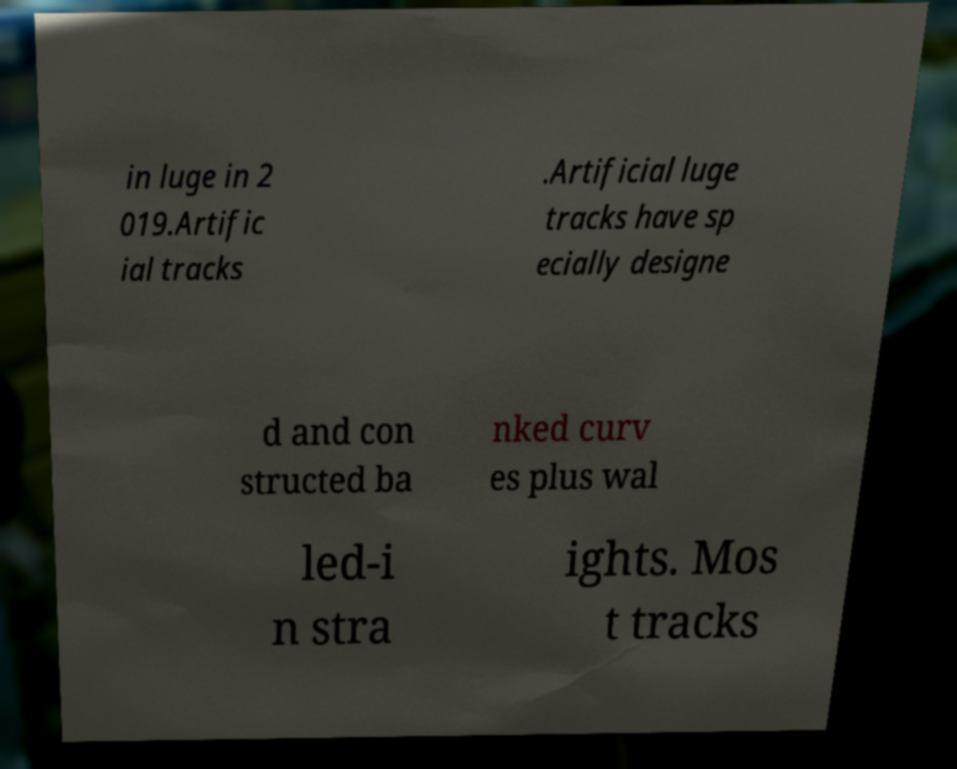Could you extract and type out the text from this image? in luge in 2 019.Artific ial tracks .Artificial luge tracks have sp ecially designe d and con structed ba nked curv es plus wal led-i n stra ights. Mos t tracks 